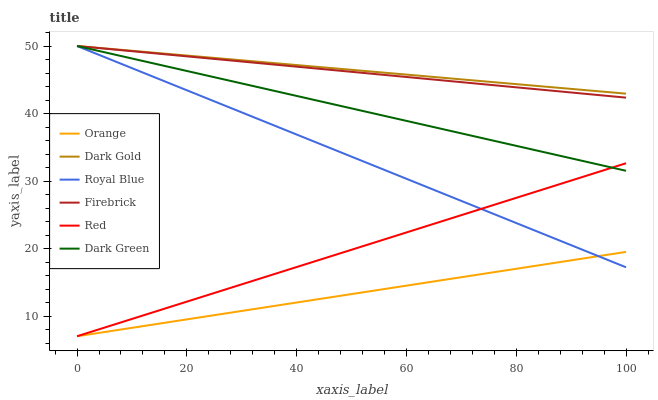Does Orange have the minimum area under the curve?
Answer yes or no. Yes. Does Dark Gold have the maximum area under the curve?
Answer yes or no. Yes. Does Firebrick have the minimum area under the curve?
Answer yes or no. No. Does Firebrick have the maximum area under the curve?
Answer yes or no. No. Is Dark Green the smoothest?
Answer yes or no. Yes. Is Firebrick the roughest?
Answer yes or no. Yes. Is Royal Blue the smoothest?
Answer yes or no. No. Is Royal Blue the roughest?
Answer yes or no. No. Does Orange have the lowest value?
Answer yes or no. Yes. Does Firebrick have the lowest value?
Answer yes or no. No. Does Dark Green have the highest value?
Answer yes or no. Yes. Does Orange have the highest value?
Answer yes or no. No. Is Red less than Firebrick?
Answer yes or no. Yes. Is Dark Gold greater than Orange?
Answer yes or no. Yes. Does Orange intersect Red?
Answer yes or no. Yes. Is Orange less than Red?
Answer yes or no. No. Is Orange greater than Red?
Answer yes or no. No. Does Red intersect Firebrick?
Answer yes or no. No. 